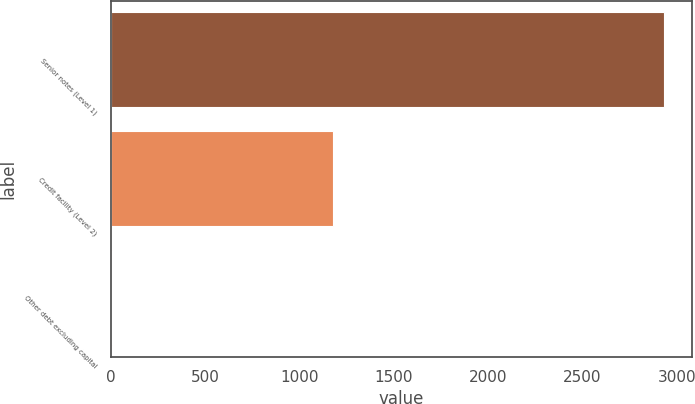<chart> <loc_0><loc_0><loc_500><loc_500><bar_chart><fcel>Senior notes (Level 1)<fcel>Credit facility (Level 2)<fcel>Other debt excluding capital<nl><fcel>2932<fcel>1178<fcel>5<nl></chart> 